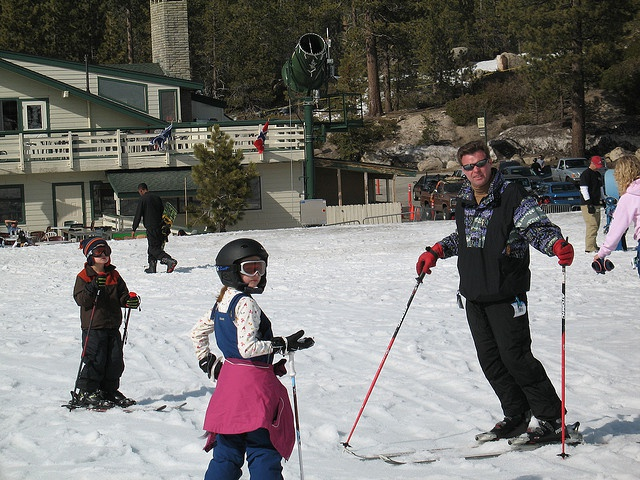Describe the objects in this image and their specific colors. I can see people in black, gray, lightgray, and darkgray tones, people in black, navy, maroon, and lightgray tones, people in black, maroon, gray, and brown tones, people in black, lavender, darkgray, gray, and pink tones, and people in black, gray, and maroon tones in this image. 